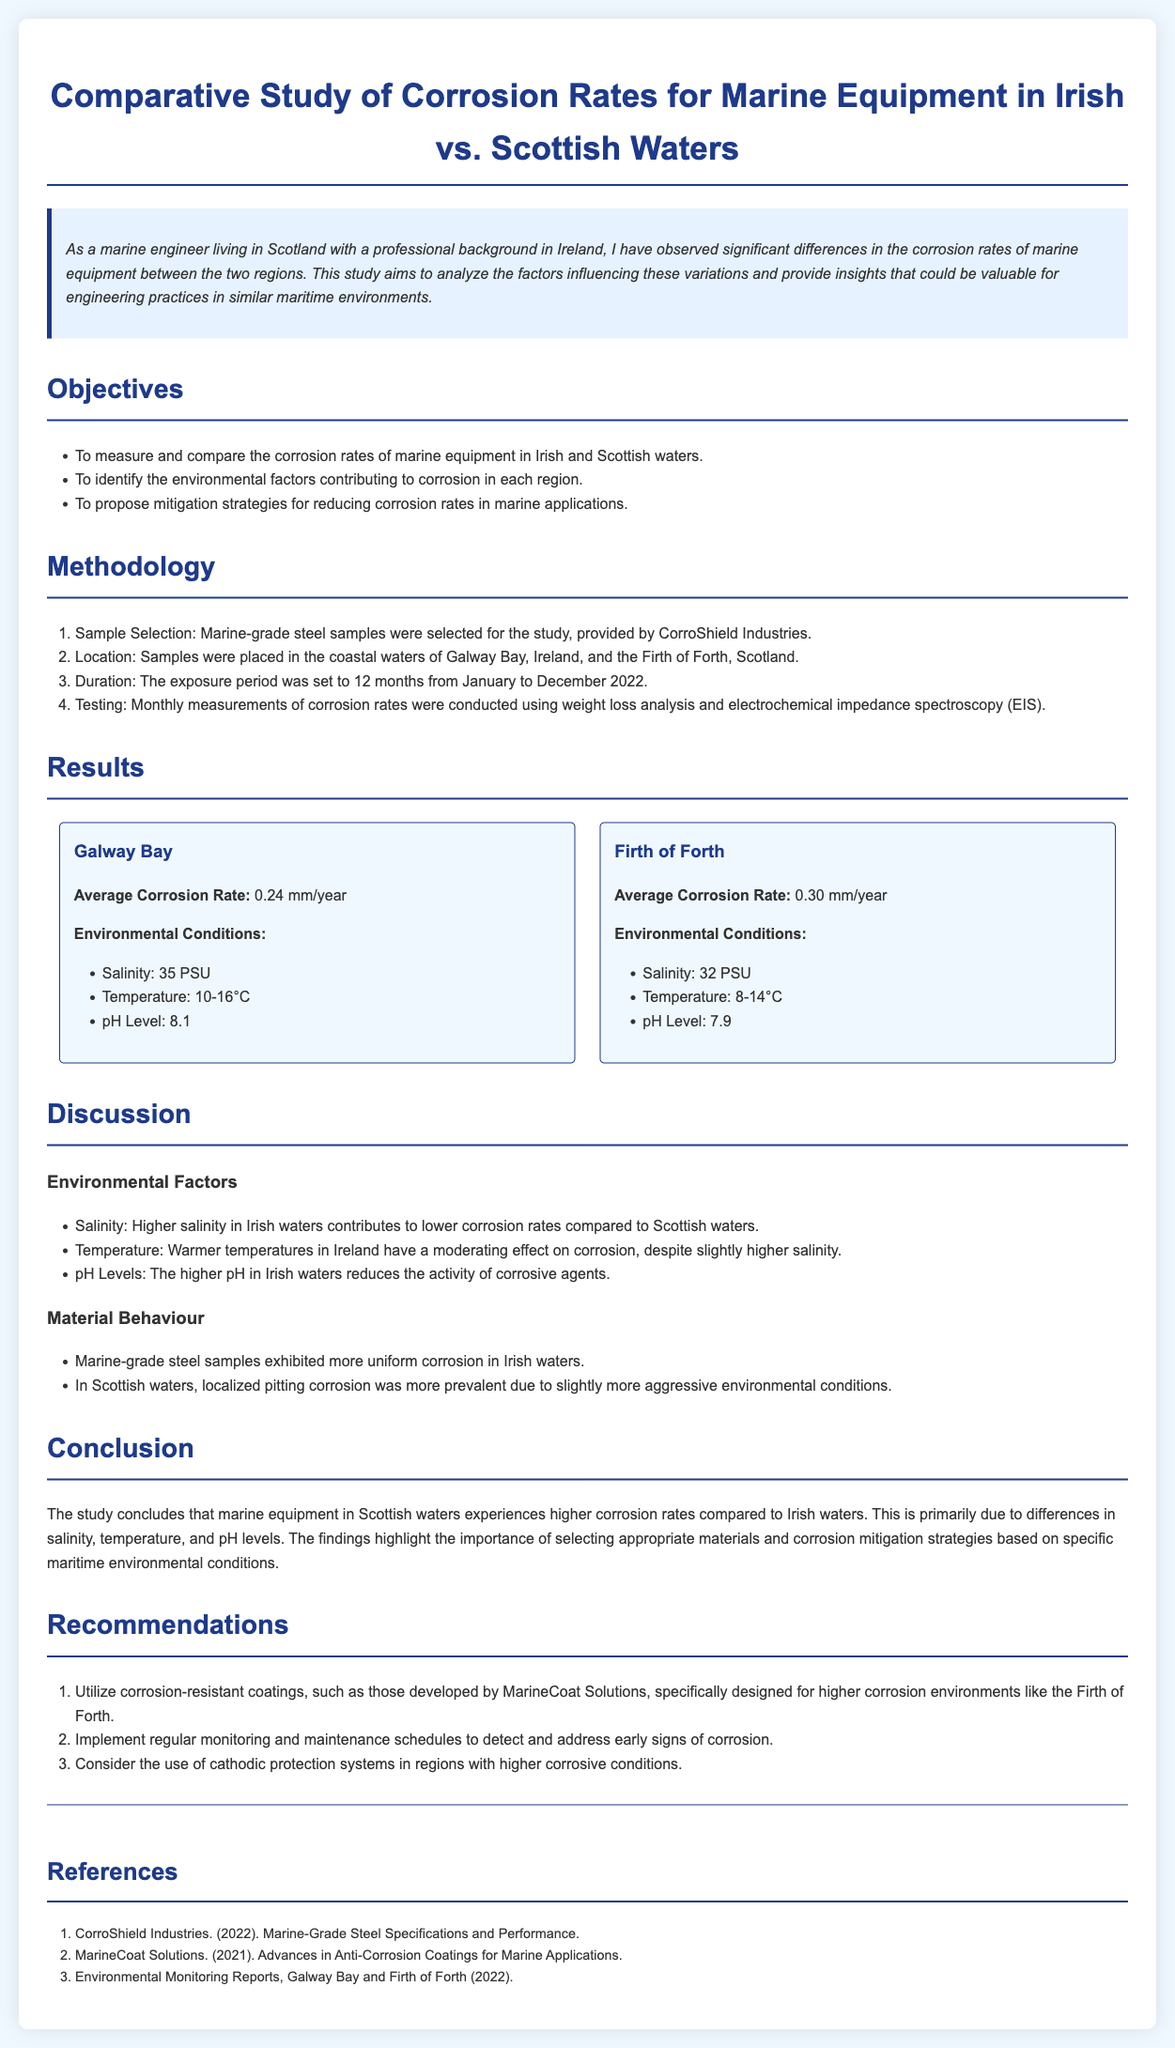What is the title of the study? The title is prominently displayed at the beginning of the document.
Answer: Comparative Study of Corrosion Rates for Marine Equipment in Irish vs. Scottish Waters What is the average corrosion rate in Galway Bay? The average corrosion rate is listed under the results section for Galway Bay.
Answer: 0.24 mm/year What environmental condition was measured with a pH level of 8.1? This information is detailed as part of the environmental conditions for Galway Bay.
Answer: pH Level Which organization provided the marine-grade steel samples? The organization is mentioned in the methodology section.
Answer: CorroShield Industries What factor contributes to higher corrosion rates in Scottish waters? This reasoning requires comparing the environmental factors discussed in the document.
Answer: Lower pH and temperature What is one recommendation for mitigating corrosion? Recommendations are provided in the last section of the document.
Answer: Utilize corrosion-resistant coatings How long was the exposure period for the samples? The duration of the exposure period is specified in the methodology section.
Answer: 12 months What two locations were tested in this study? The locations are mentioned in both the sample selection and results sections.
Answer: Galway Bay and Firth of Forth 